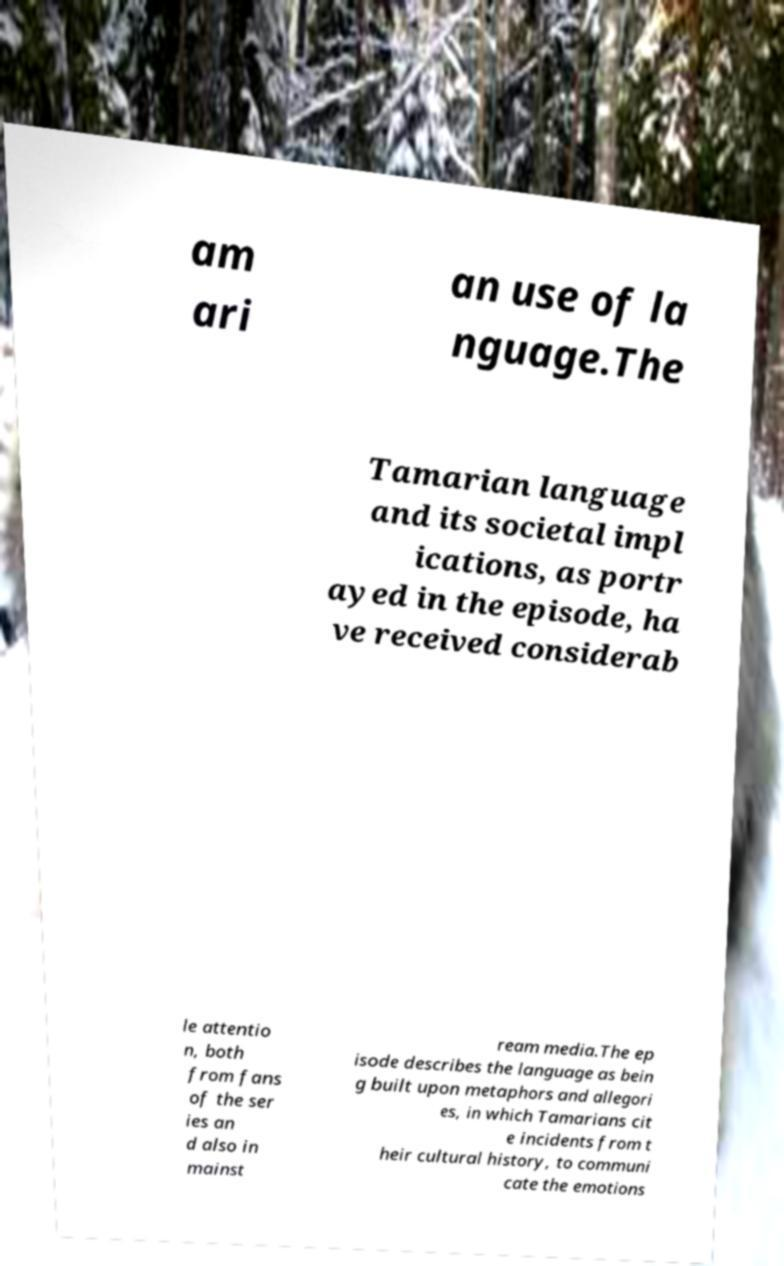Please read and relay the text visible in this image. What does it say? am ari an use of la nguage.The Tamarian language and its societal impl ications, as portr ayed in the episode, ha ve received considerab le attentio n, both from fans of the ser ies an d also in mainst ream media.The ep isode describes the language as bein g built upon metaphors and allegori es, in which Tamarians cit e incidents from t heir cultural history, to communi cate the emotions 